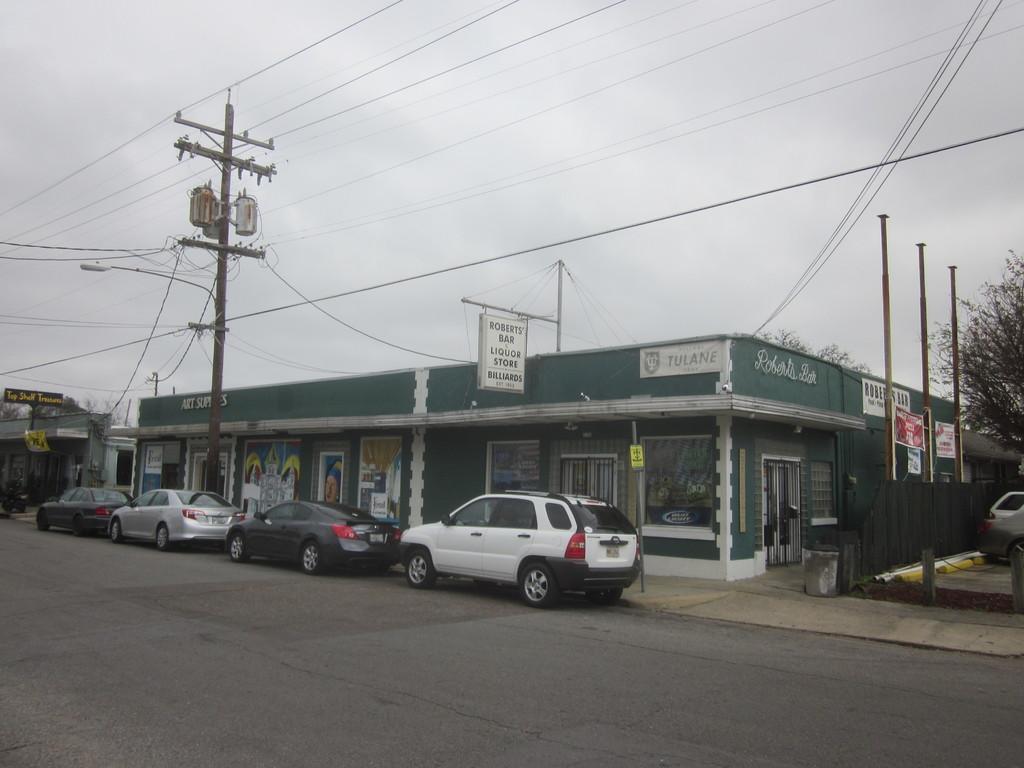Could you give a brief overview of what you see in this image? In this image, we can see some vehicles, buildings, poles, wires, trees. We can see the ground. We can also see some boards with text. We can see the sky. 